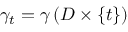<formula> <loc_0><loc_0><loc_500><loc_500>\gamma _ { t } = \gamma \left ( D \times \{ t \} \right )</formula> 